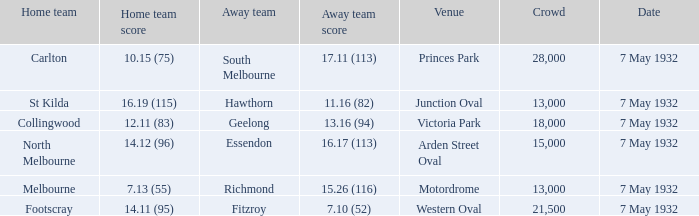What is the away team with a Crowd greater than 13,000, and a Home team score of 12.11 (83)? Geelong. 